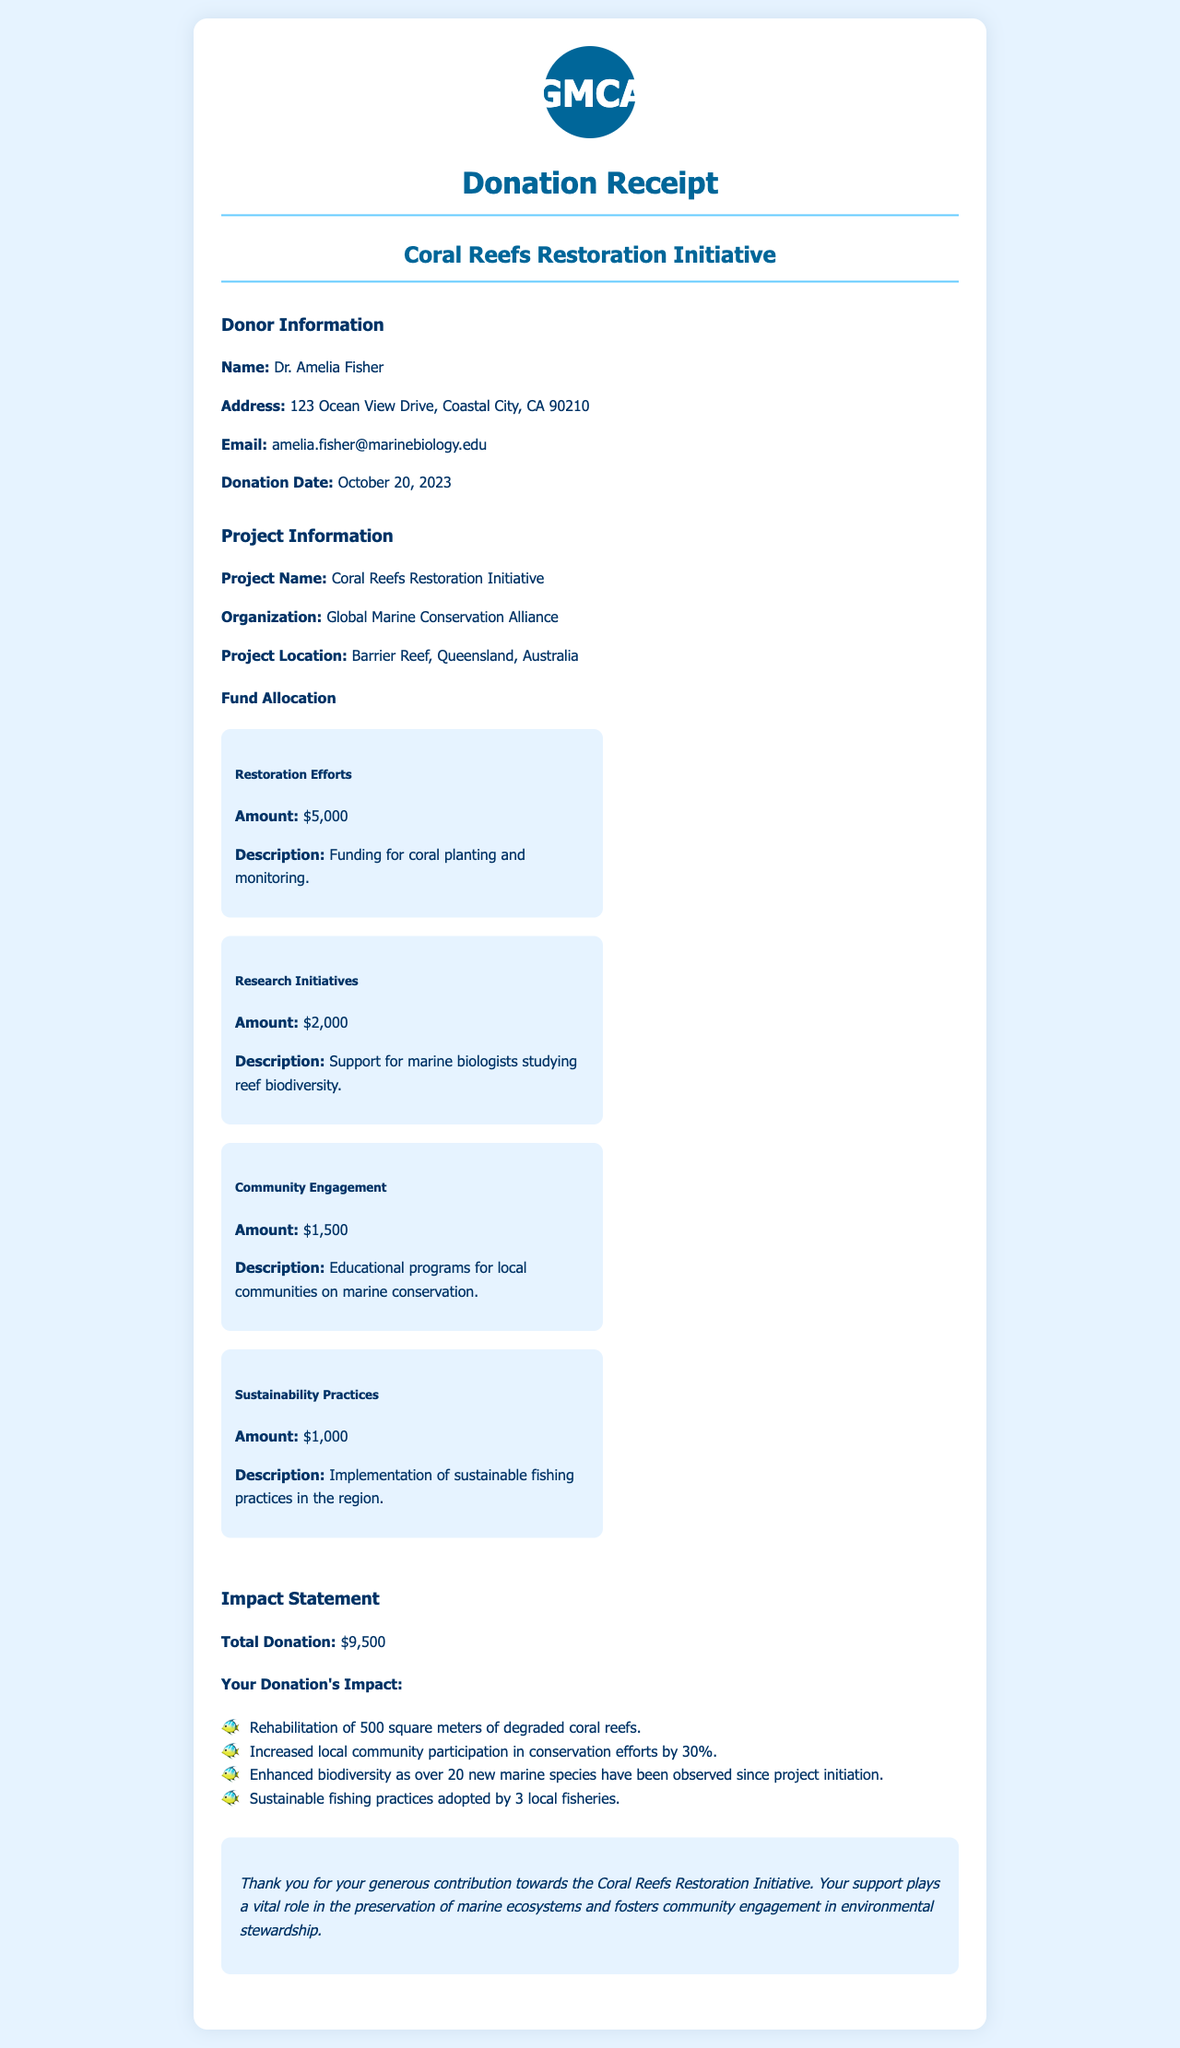What is the donor's name? The donor's name is explicitly mentioned in the document under Donor Information as Dr. Amelia Fisher.
Answer: Dr. Amelia Fisher What is the donation amount? The total donation amount can be found in the Impact Statement section, which sums up all funds allocated.
Answer: $9,500 What is the project location? The project location is detailed under Project Information, specifying that it is at the Barrier Reef in Queensland, Australia.
Answer: Barrier Reef, Queensland, Australia How much funding is allocated for Restoration Efforts? The document specifies the amount allocated for Restoration Efforts in the Fund Allocation section.
Answer: $5,000 What percentage increase in community participation is reported? The increase in community participation is noted in the Impact Statement section as 30%.
Answer: 30% What organization is conducting the project? The organization conducting the project is stated in the Project Information section as the Global Marine Conservation Alliance.
Answer: Global Marine Conservation Alliance How many square meters of coral reefs are being rehabilitated? This information is provided in the Impact Statement, specifying the area undergoing rehabilitation.
Answer: 500 square meters What sustainable practice is mentioned in the fund allocation? The fund allocation mentions the implementation of sustainable fishing practices as a specific initiative.
Answer: Sustainable fishing practices How many new marine species have been observed? The Impact Statement section includes the number of new marine species that have been observed since the project's initiation.
Answer: 20 new marine species 